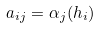Convert formula to latex. <formula><loc_0><loc_0><loc_500><loc_500>a _ { i j } = \alpha _ { j } ( h _ { i } )</formula> 